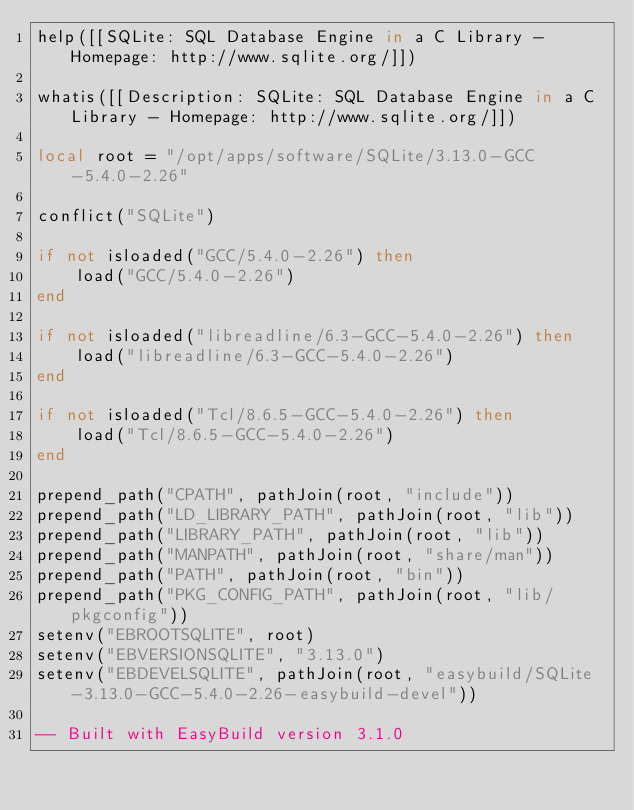<code> <loc_0><loc_0><loc_500><loc_500><_Lua_>help([[SQLite: SQL Database Engine in a C Library - Homepage: http://www.sqlite.org/]])

whatis([[Description: SQLite: SQL Database Engine in a C Library - Homepage: http://www.sqlite.org/]])

local root = "/opt/apps/software/SQLite/3.13.0-GCC-5.4.0-2.26"

conflict("SQLite")

if not isloaded("GCC/5.4.0-2.26") then
    load("GCC/5.4.0-2.26")
end

if not isloaded("libreadline/6.3-GCC-5.4.0-2.26") then
    load("libreadline/6.3-GCC-5.4.0-2.26")
end

if not isloaded("Tcl/8.6.5-GCC-5.4.0-2.26") then
    load("Tcl/8.6.5-GCC-5.4.0-2.26")
end

prepend_path("CPATH", pathJoin(root, "include"))
prepend_path("LD_LIBRARY_PATH", pathJoin(root, "lib"))
prepend_path("LIBRARY_PATH", pathJoin(root, "lib"))
prepend_path("MANPATH", pathJoin(root, "share/man"))
prepend_path("PATH", pathJoin(root, "bin"))
prepend_path("PKG_CONFIG_PATH", pathJoin(root, "lib/pkgconfig"))
setenv("EBROOTSQLITE", root)
setenv("EBVERSIONSQLITE", "3.13.0")
setenv("EBDEVELSQLITE", pathJoin(root, "easybuild/SQLite-3.13.0-GCC-5.4.0-2.26-easybuild-devel"))

-- Built with EasyBuild version 3.1.0
</code> 